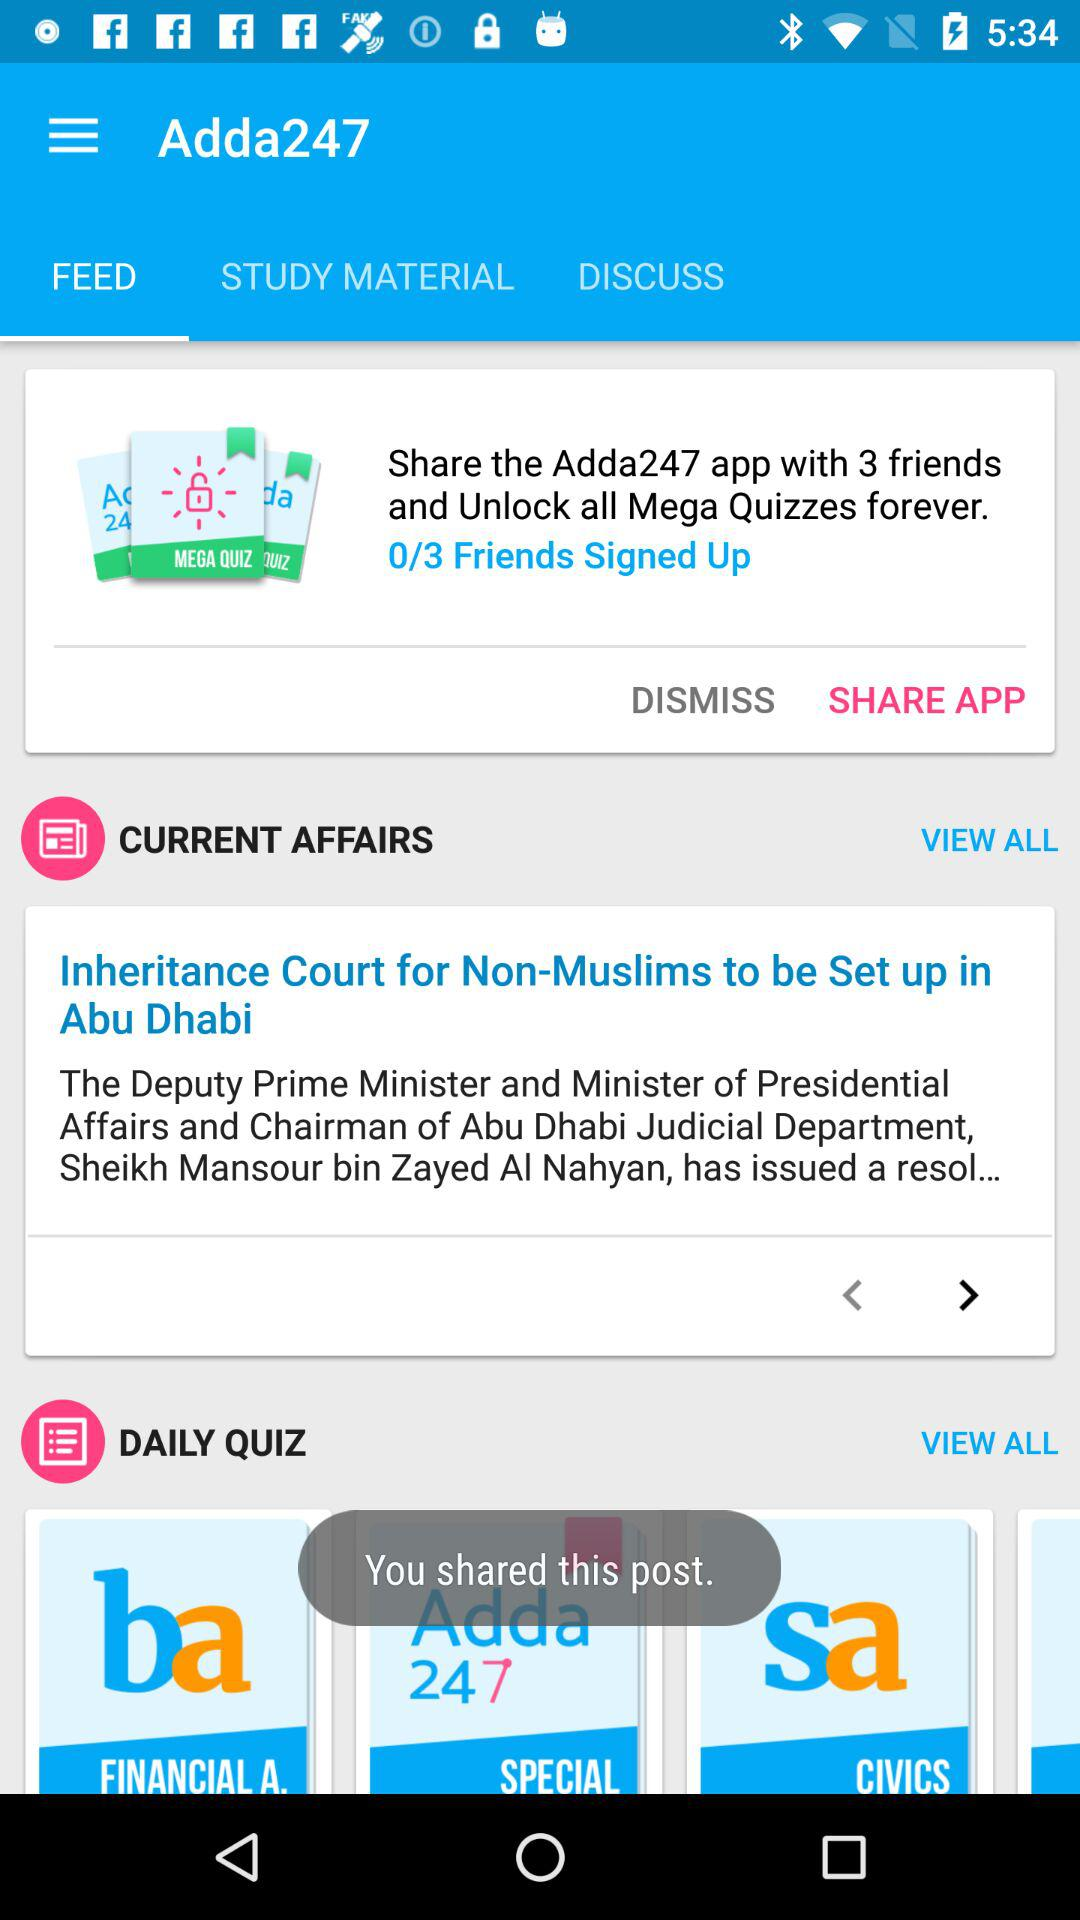Which option is selected in Adda247? The selected option is "FEED". 